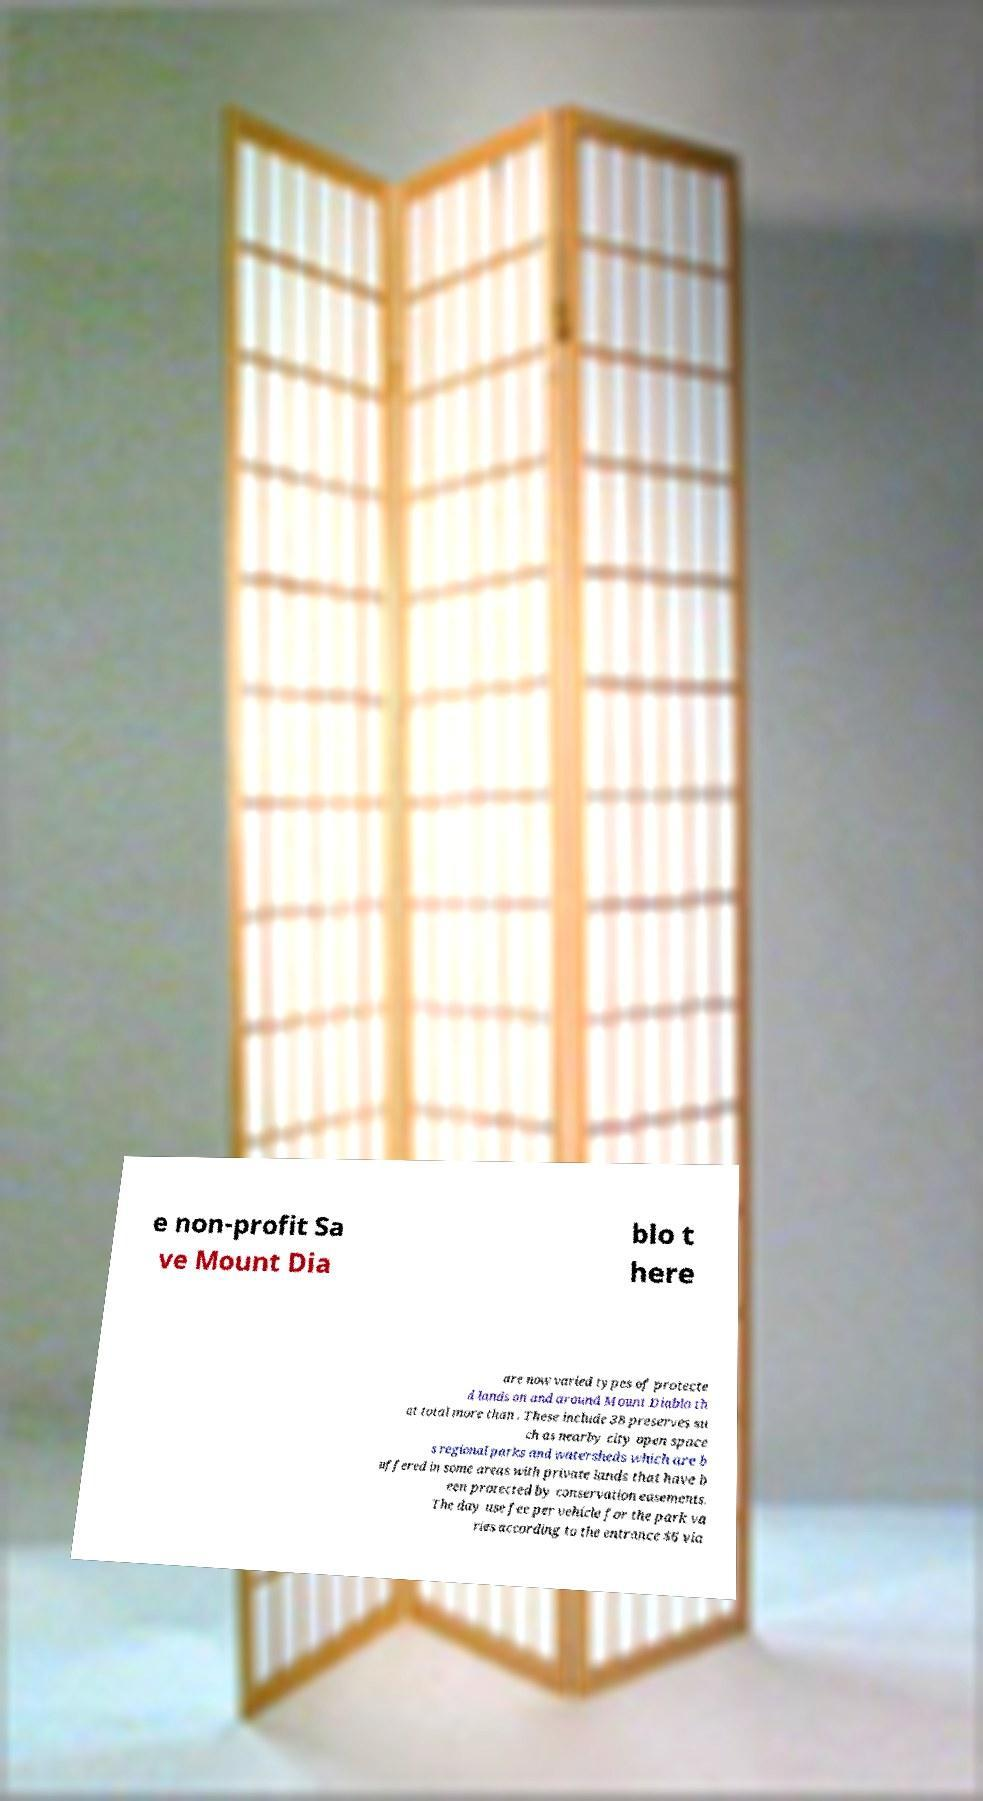For documentation purposes, I need the text within this image transcribed. Could you provide that? e non-profit Sa ve Mount Dia blo t here are now varied types of protecte d lands on and around Mount Diablo th at total more than . These include 38 preserves su ch as nearby city open space s regional parks and watersheds which are b uffered in some areas with private lands that have b een protected by conservation easements. The day use fee per vehicle for the park va ries according to the entrance $6 via 